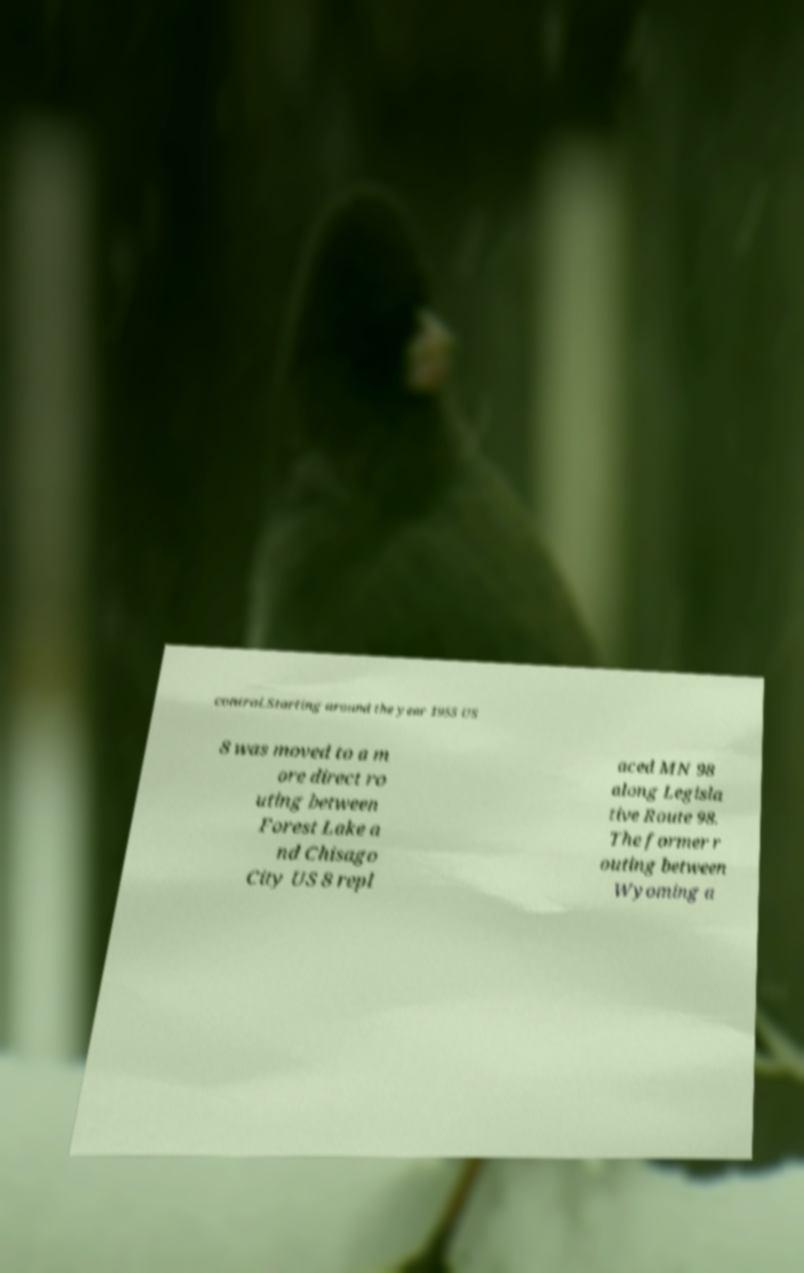Please identify and transcribe the text found in this image. control.Starting around the year 1955 US 8 was moved to a m ore direct ro uting between Forest Lake a nd Chisago City US 8 repl aced MN 98 along Legisla tive Route 98. The former r outing between Wyoming a 